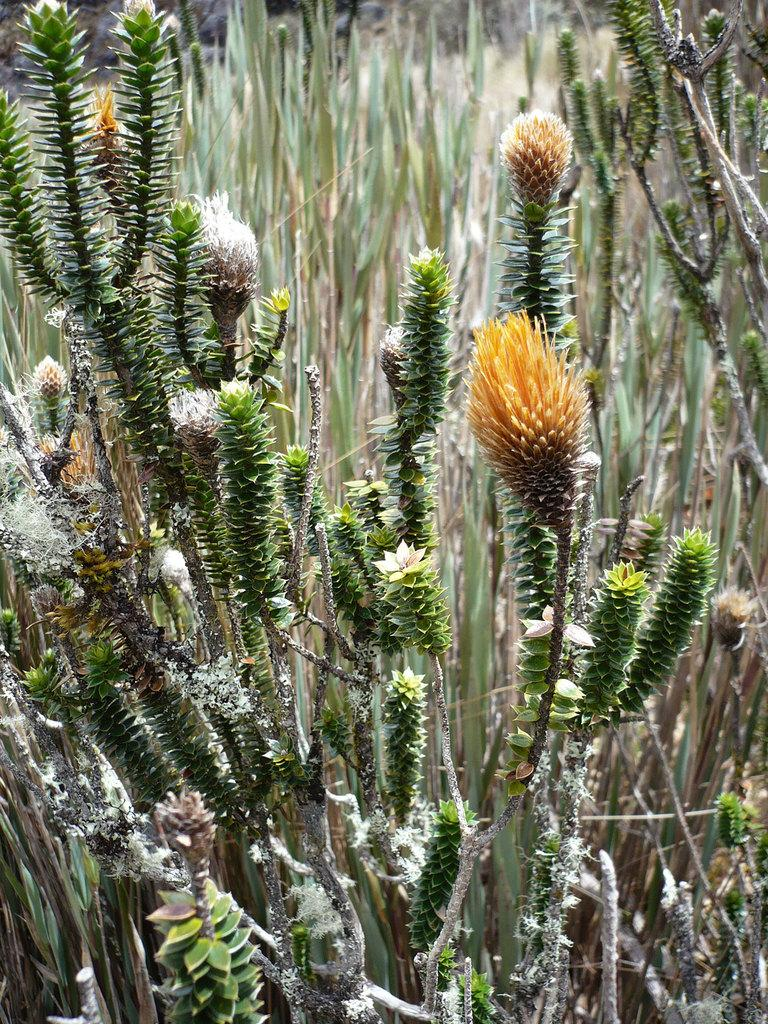What type of living organism is present in the image? There is a plant in the image. What are the main features of the plant? The plant has branches, leaves, and flowers. What might be the classification of the plant? The plant may be a type of grass. What is the plant doing to soothe its throat in the image? There is no indication in the image that the plant has a throat or is experiencing any discomfort. 